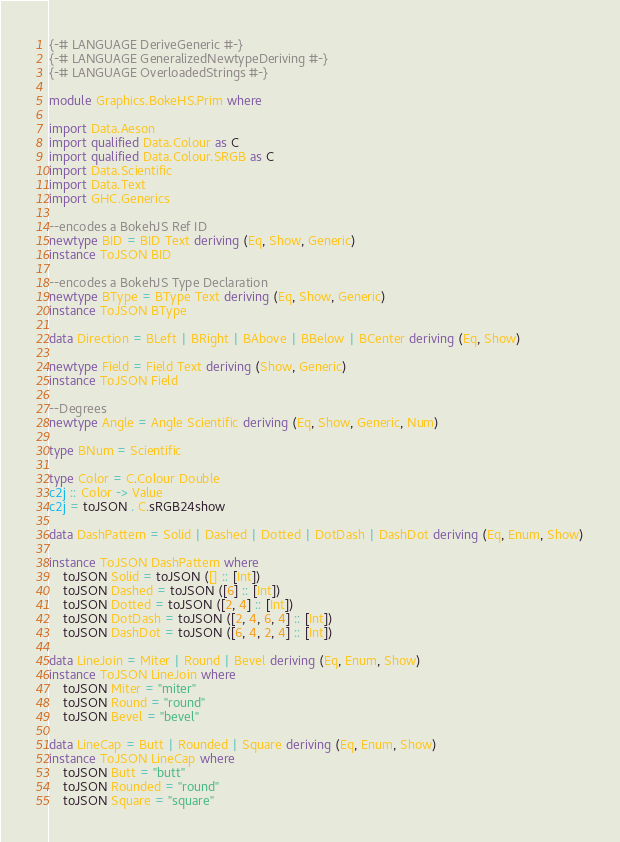<code> <loc_0><loc_0><loc_500><loc_500><_Haskell_>{-# LANGUAGE DeriveGeneric #-}
{-# LANGUAGE GeneralizedNewtypeDeriving #-}
{-# LANGUAGE OverloadedStrings #-}

module Graphics.BokeHS.Prim where

import Data.Aeson
import qualified Data.Colour as C
import qualified Data.Colour.SRGB as C
import Data.Scientific
import Data.Text
import GHC.Generics

--encodes a BokehJS Ref ID
newtype BID = BID Text deriving (Eq, Show, Generic)
instance ToJSON BID

--encodes a BokehJS Type Declaration
newtype BType = BType Text deriving (Eq, Show, Generic)
instance ToJSON BType

data Direction = BLeft | BRight | BAbove | BBelow | BCenter deriving (Eq, Show)

newtype Field = Field Text deriving (Show, Generic)
instance ToJSON Field

--Degrees
newtype Angle = Angle Scientific deriving (Eq, Show, Generic, Num)

type BNum = Scientific

type Color = C.Colour Double
c2j :: Color -> Value
c2j = toJSON . C.sRGB24show

data DashPattern = Solid | Dashed | Dotted | DotDash | DashDot deriving (Eq, Enum, Show)

instance ToJSON DashPattern where
    toJSON Solid = toJSON ([] :: [Int])
    toJSON Dashed = toJSON ([6] :: [Int])
    toJSON Dotted = toJSON ([2, 4] :: [Int])
    toJSON DotDash = toJSON ([2, 4, 6, 4] :: [Int])
    toJSON DashDot = toJSON ([6, 4, 2, 4] :: [Int])

data LineJoin = Miter | Round | Bevel deriving (Eq, Enum, Show)
instance ToJSON LineJoin where
    toJSON Miter = "miter"
    toJSON Round = "round"
    toJSON Bevel = "bevel"

data LineCap = Butt | Rounded | Square deriving (Eq, Enum, Show)
instance ToJSON LineCap where
    toJSON Butt = "butt"
    toJSON Rounded = "round"
    toJSON Square = "square"

</code> 